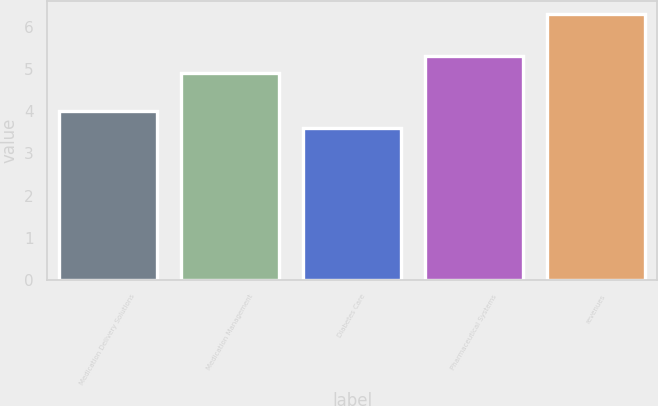Convert chart. <chart><loc_0><loc_0><loc_500><loc_500><bar_chart><fcel>Medication Delivery Solutions<fcel>Medication Management<fcel>Diabetes Care<fcel>Pharmaceutical Systems<fcel>revenues<nl><fcel>4<fcel>4.9<fcel>3.6<fcel>5.3<fcel>6.3<nl></chart> 